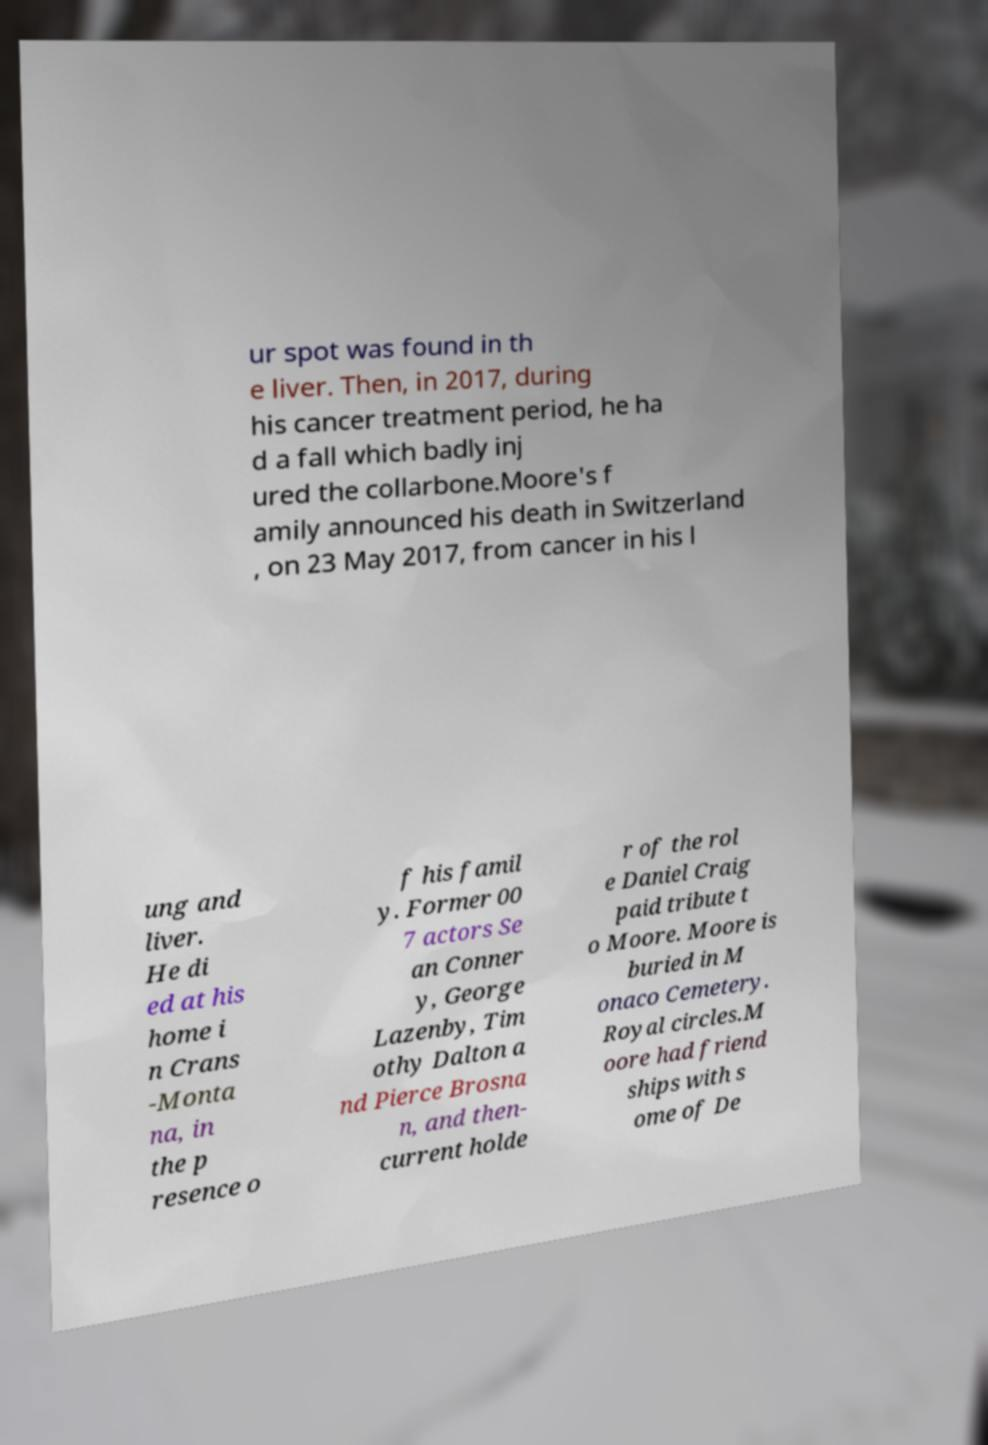Please read and relay the text visible in this image. What does it say? ur spot was found in th e liver. Then, in 2017, during his cancer treatment period, he ha d a fall which badly inj ured the collarbone.Moore's f amily announced his death in Switzerland , on 23 May 2017, from cancer in his l ung and liver. He di ed at his home i n Crans -Monta na, in the p resence o f his famil y. Former 00 7 actors Se an Conner y, George Lazenby, Tim othy Dalton a nd Pierce Brosna n, and then- current holde r of the rol e Daniel Craig paid tribute t o Moore. Moore is buried in M onaco Cemetery. Royal circles.M oore had friend ships with s ome of De 